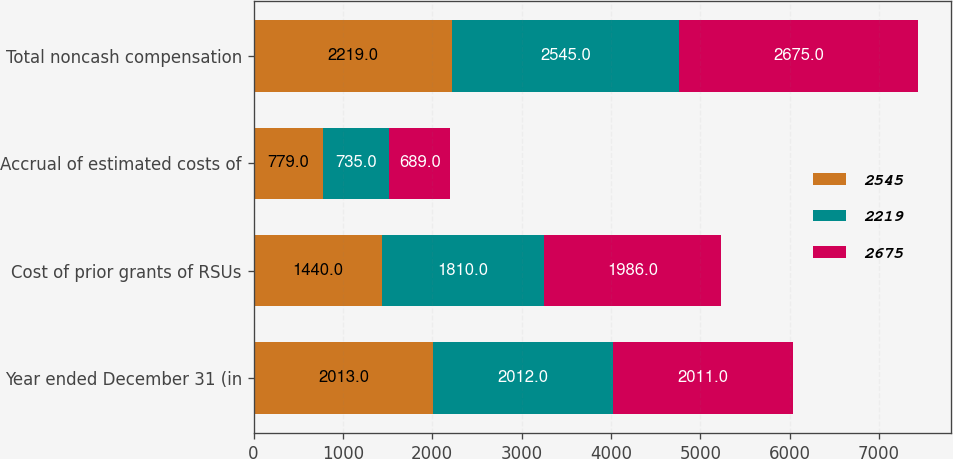Convert chart to OTSL. <chart><loc_0><loc_0><loc_500><loc_500><stacked_bar_chart><ecel><fcel>Year ended December 31 (in<fcel>Cost of prior grants of RSUs<fcel>Accrual of estimated costs of<fcel>Total noncash compensation<nl><fcel>2545<fcel>2013<fcel>1440<fcel>779<fcel>2219<nl><fcel>2219<fcel>2012<fcel>1810<fcel>735<fcel>2545<nl><fcel>2675<fcel>2011<fcel>1986<fcel>689<fcel>2675<nl></chart> 